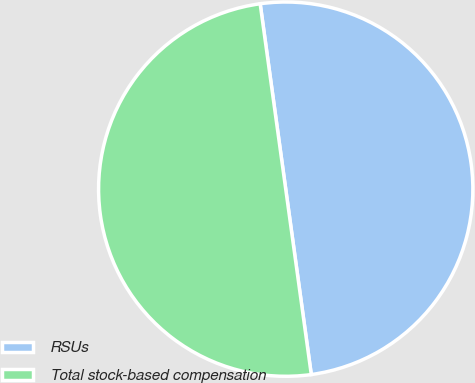Convert chart. <chart><loc_0><loc_0><loc_500><loc_500><pie_chart><fcel>RSUs<fcel>Total stock-based compensation<nl><fcel>50.0%<fcel>50.0%<nl></chart> 